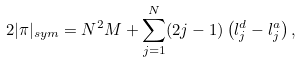Convert formula to latex. <formula><loc_0><loc_0><loc_500><loc_500>2 | \pi | _ { s y m } = N ^ { 2 } M + \sum _ { j = 1 } ^ { N } ( 2 j - 1 ) \left ( l _ { j } ^ { d } - l _ { j } ^ { a } \right ) ,</formula> 